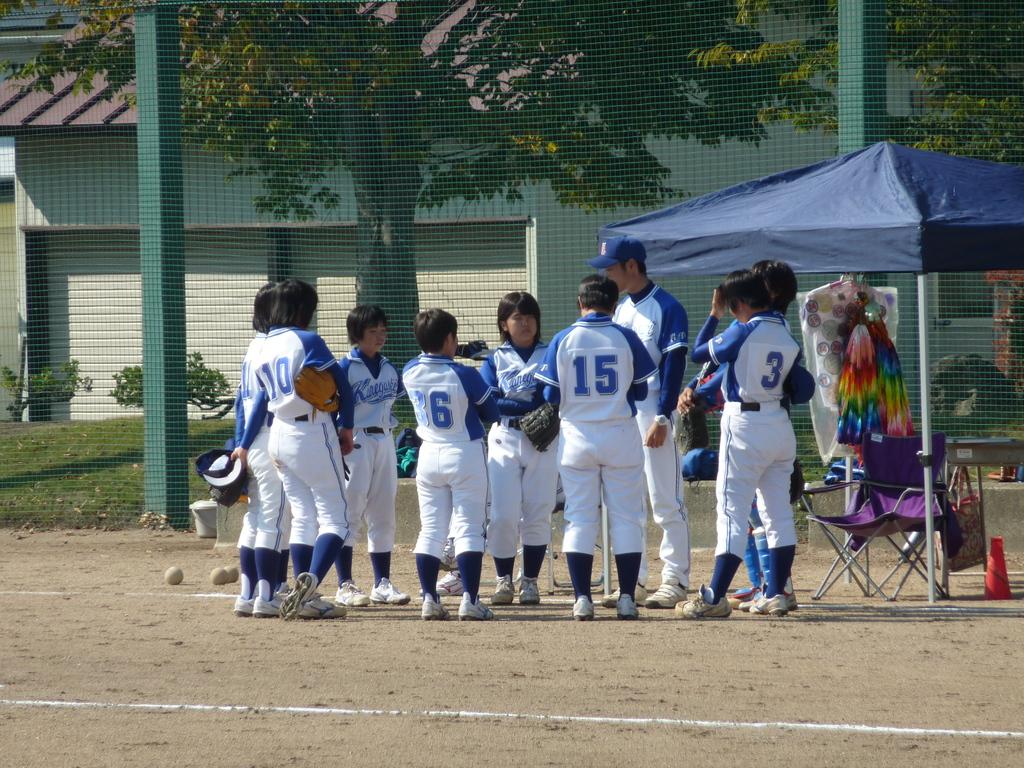What number payer is to the far right?
Keep it short and to the point. 3. What number is on the far left?
Make the answer very short. 10. 